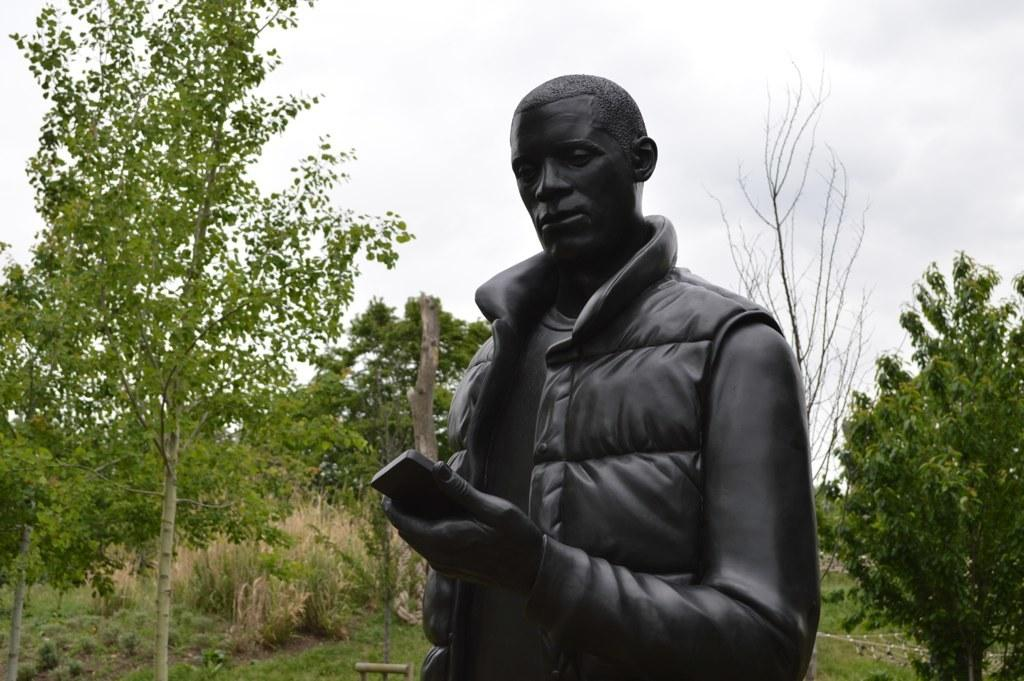What is the main subject in the front of the image? There is a statue in the front of the image. What can be seen in the background of the image? There are trees in the background of the image. What is visible at the top of the image? The sky is visible at the top of the image. What type of skin condition does the statue have in the image? The statue is an inanimate object and does not have a skin condition. Can you hear the drum being played in the image? There is no drum or any sound mentioned in the image, so it cannot be heard. 